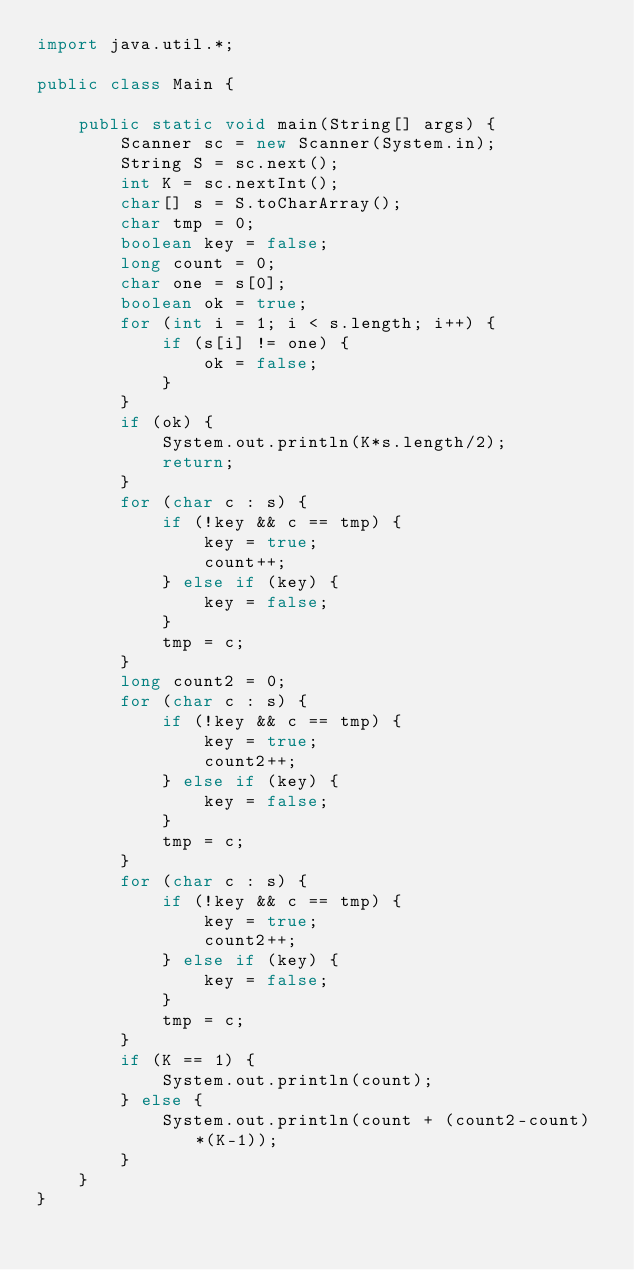Convert code to text. <code><loc_0><loc_0><loc_500><loc_500><_Java_>import java.util.*;

public class Main {
    
    public static void main(String[] args) {
        Scanner sc = new Scanner(System.in);
        String S = sc.next();
        int K = sc.nextInt();
        char[] s = S.toCharArray();
        char tmp = 0;
        boolean key = false;
        long count = 0;
        char one = s[0];
        boolean ok = true;
        for (int i = 1; i < s.length; i++) {
            if (s[i] != one) {
                ok = false;
            }
        }
        if (ok) {
            System.out.println(K*s.length/2);
            return;
        }
        for (char c : s) {
            if (!key && c == tmp) {
                key = true;
                count++;
            } else if (key) {
                key = false;
            }
            tmp = c;
        }
        long count2 = 0;
        for (char c : s) {
            if (!key && c == tmp) {
                key = true;
                count2++;
            } else if (key) {
                key = false;
            }
            tmp = c;
        }
        for (char c : s) {
            if (!key && c == tmp) {
                key = true;
                count2++;
            } else if (key) {
                key = false;
            }
            tmp = c;
        }
        if (K == 1) {
            System.out.println(count);
        } else {
            System.out.println(count + (count2-count)*(K-1));
        }
    }
}</code> 